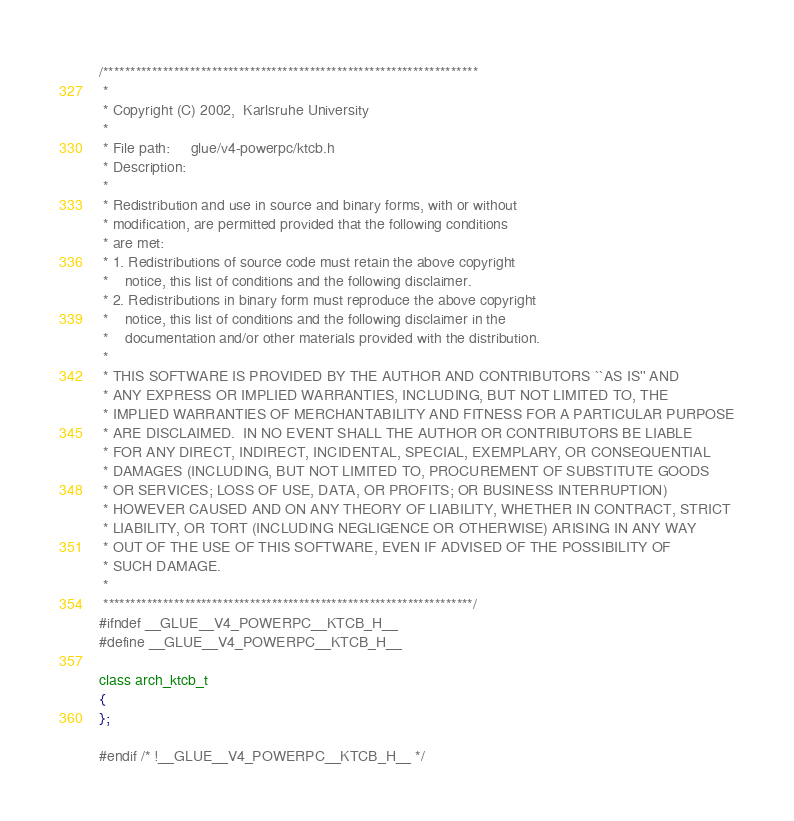<code> <loc_0><loc_0><loc_500><loc_500><_C_>/*********************************************************************
 *                
 * Copyright (C) 2002,  Karlsruhe University
 *                
 * File path:     glue/v4-powerpc/ktcb.h
 * Description:   
 *                
 * Redistribution and use in source and binary forms, with or without
 * modification, are permitted provided that the following conditions
 * are met:
 * 1. Redistributions of source code must retain the above copyright
 *    notice, this list of conditions and the following disclaimer.
 * 2. Redistributions in binary form must reproduce the above copyright
 *    notice, this list of conditions and the following disclaimer in the
 *    documentation and/or other materials provided with the distribution.
 * 
 * THIS SOFTWARE IS PROVIDED BY THE AUTHOR AND CONTRIBUTORS ``AS IS'' AND
 * ANY EXPRESS OR IMPLIED WARRANTIES, INCLUDING, BUT NOT LIMITED TO, THE
 * IMPLIED WARRANTIES OF MERCHANTABILITY AND FITNESS FOR A PARTICULAR PURPOSE
 * ARE DISCLAIMED.  IN NO EVENT SHALL THE AUTHOR OR CONTRIBUTORS BE LIABLE
 * FOR ANY DIRECT, INDIRECT, INCIDENTAL, SPECIAL, EXEMPLARY, OR CONSEQUENTIAL
 * DAMAGES (INCLUDING, BUT NOT LIMITED TO, PROCUREMENT OF SUBSTITUTE GOODS
 * OR SERVICES; LOSS OF USE, DATA, OR PROFITS; OR BUSINESS INTERRUPTION)
 * HOWEVER CAUSED AND ON ANY THEORY OF LIABILITY, WHETHER IN CONTRACT, STRICT
 * LIABILITY, OR TORT (INCLUDING NEGLIGENCE OR OTHERWISE) ARISING IN ANY WAY
 * OUT OF THE USE OF THIS SOFTWARE, EVEN IF ADVISED OF THE POSSIBILITY OF
 * SUCH DAMAGE.
 *                
 ********************************************************************/
#ifndef __GLUE__V4_POWERPC__KTCB_H__
#define __GLUE__V4_POWERPC__KTCB_H__

class arch_ktcb_t
{
};

#endif /* !__GLUE__V4_POWERPC__KTCB_H__ */
</code> 